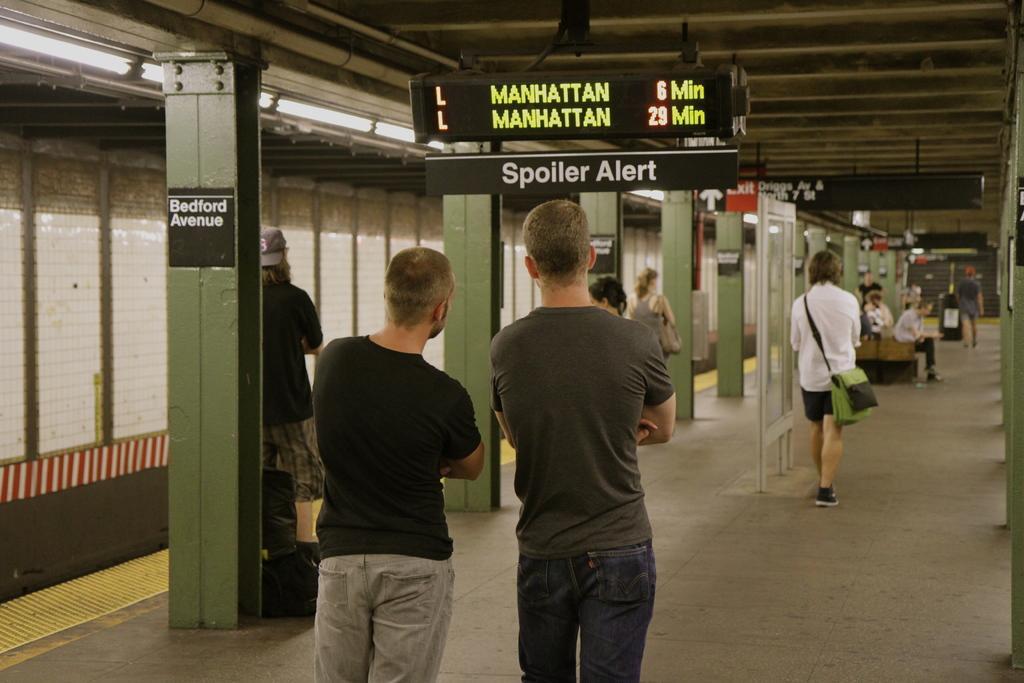Could you give a brief overview of what you see in this image? In this image we can see a group of people standing on the ground. One person is carrying a bag. To the right side of the image we can some people sitting. At the top of the image we can see sign board with some text. In the background, we can see a group of poles. In the top right corner we can see a staircase. 